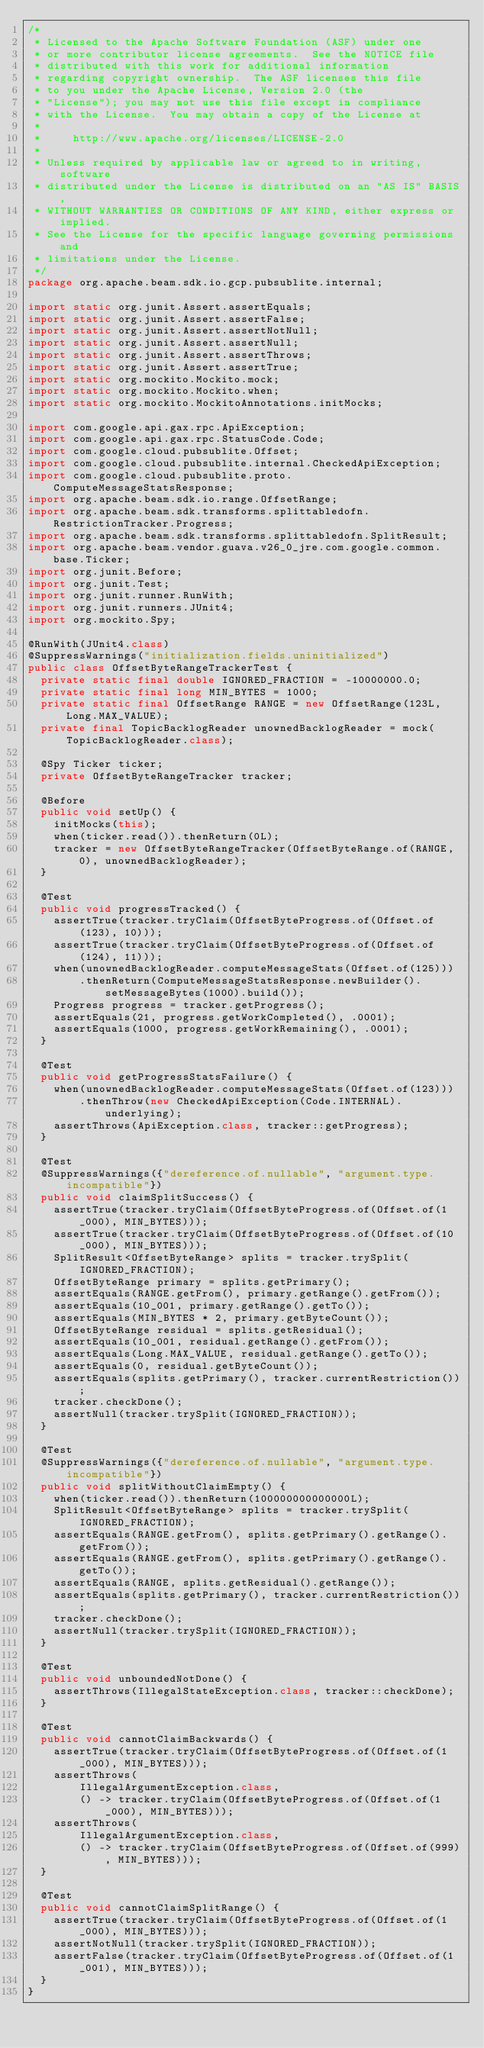Convert code to text. <code><loc_0><loc_0><loc_500><loc_500><_Java_>/*
 * Licensed to the Apache Software Foundation (ASF) under one
 * or more contributor license agreements.  See the NOTICE file
 * distributed with this work for additional information
 * regarding copyright ownership.  The ASF licenses this file
 * to you under the Apache License, Version 2.0 (the
 * "License"); you may not use this file except in compliance
 * with the License.  You may obtain a copy of the License at
 *
 *     http://www.apache.org/licenses/LICENSE-2.0
 *
 * Unless required by applicable law or agreed to in writing, software
 * distributed under the License is distributed on an "AS IS" BASIS,
 * WITHOUT WARRANTIES OR CONDITIONS OF ANY KIND, either express or implied.
 * See the License for the specific language governing permissions and
 * limitations under the License.
 */
package org.apache.beam.sdk.io.gcp.pubsublite.internal;

import static org.junit.Assert.assertEquals;
import static org.junit.Assert.assertFalse;
import static org.junit.Assert.assertNotNull;
import static org.junit.Assert.assertNull;
import static org.junit.Assert.assertThrows;
import static org.junit.Assert.assertTrue;
import static org.mockito.Mockito.mock;
import static org.mockito.Mockito.when;
import static org.mockito.MockitoAnnotations.initMocks;

import com.google.api.gax.rpc.ApiException;
import com.google.api.gax.rpc.StatusCode.Code;
import com.google.cloud.pubsublite.Offset;
import com.google.cloud.pubsublite.internal.CheckedApiException;
import com.google.cloud.pubsublite.proto.ComputeMessageStatsResponse;
import org.apache.beam.sdk.io.range.OffsetRange;
import org.apache.beam.sdk.transforms.splittabledofn.RestrictionTracker.Progress;
import org.apache.beam.sdk.transforms.splittabledofn.SplitResult;
import org.apache.beam.vendor.guava.v26_0_jre.com.google.common.base.Ticker;
import org.junit.Before;
import org.junit.Test;
import org.junit.runner.RunWith;
import org.junit.runners.JUnit4;
import org.mockito.Spy;

@RunWith(JUnit4.class)
@SuppressWarnings("initialization.fields.uninitialized")
public class OffsetByteRangeTrackerTest {
  private static final double IGNORED_FRACTION = -10000000.0;
  private static final long MIN_BYTES = 1000;
  private static final OffsetRange RANGE = new OffsetRange(123L, Long.MAX_VALUE);
  private final TopicBacklogReader unownedBacklogReader = mock(TopicBacklogReader.class);

  @Spy Ticker ticker;
  private OffsetByteRangeTracker tracker;

  @Before
  public void setUp() {
    initMocks(this);
    when(ticker.read()).thenReturn(0L);
    tracker = new OffsetByteRangeTracker(OffsetByteRange.of(RANGE, 0), unownedBacklogReader);
  }

  @Test
  public void progressTracked() {
    assertTrue(tracker.tryClaim(OffsetByteProgress.of(Offset.of(123), 10)));
    assertTrue(tracker.tryClaim(OffsetByteProgress.of(Offset.of(124), 11)));
    when(unownedBacklogReader.computeMessageStats(Offset.of(125)))
        .thenReturn(ComputeMessageStatsResponse.newBuilder().setMessageBytes(1000).build());
    Progress progress = tracker.getProgress();
    assertEquals(21, progress.getWorkCompleted(), .0001);
    assertEquals(1000, progress.getWorkRemaining(), .0001);
  }

  @Test
  public void getProgressStatsFailure() {
    when(unownedBacklogReader.computeMessageStats(Offset.of(123)))
        .thenThrow(new CheckedApiException(Code.INTERNAL).underlying);
    assertThrows(ApiException.class, tracker::getProgress);
  }

  @Test
  @SuppressWarnings({"dereference.of.nullable", "argument.type.incompatible"})
  public void claimSplitSuccess() {
    assertTrue(tracker.tryClaim(OffsetByteProgress.of(Offset.of(1_000), MIN_BYTES)));
    assertTrue(tracker.tryClaim(OffsetByteProgress.of(Offset.of(10_000), MIN_BYTES)));
    SplitResult<OffsetByteRange> splits = tracker.trySplit(IGNORED_FRACTION);
    OffsetByteRange primary = splits.getPrimary();
    assertEquals(RANGE.getFrom(), primary.getRange().getFrom());
    assertEquals(10_001, primary.getRange().getTo());
    assertEquals(MIN_BYTES * 2, primary.getByteCount());
    OffsetByteRange residual = splits.getResidual();
    assertEquals(10_001, residual.getRange().getFrom());
    assertEquals(Long.MAX_VALUE, residual.getRange().getTo());
    assertEquals(0, residual.getByteCount());
    assertEquals(splits.getPrimary(), tracker.currentRestriction());
    tracker.checkDone();
    assertNull(tracker.trySplit(IGNORED_FRACTION));
  }

  @Test
  @SuppressWarnings({"dereference.of.nullable", "argument.type.incompatible"})
  public void splitWithoutClaimEmpty() {
    when(ticker.read()).thenReturn(100000000000000L);
    SplitResult<OffsetByteRange> splits = tracker.trySplit(IGNORED_FRACTION);
    assertEquals(RANGE.getFrom(), splits.getPrimary().getRange().getFrom());
    assertEquals(RANGE.getFrom(), splits.getPrimary().getRange().getTo());
    assertEquals(RANGE, splits.getResidual().getRange());
    assertEquals(splits.getPrimary(), tracker.currentRestriction());
    tracker.checkDone();
    assertNull(tracker.trySplit(IGNORED_FRACTION));
  }

  @Test
  public void unboundedNotDone() {
    assertThrows(IllegalStateException.class, tracker::checkDone);
  }

  @Test
  public void cannotClaimBackwards() {
    assertTrue(tracker.tryClaim(OffsetByteProgress.of(Offset.of(1_000), MIN_BYTES)));
    assertThrows(
        IllegalArgumentException.class,
        () -> tracker.tryClaim(OffsetByteProgress.of(Offset.of(1_000), MIN_BYTES)));
    assertThrows(
        IllegalArgumentException.class,
        () -> tracker.tryClaim(OffsetByteProgress.of(Offset.of(999), MIN_BYTES)));
  }

  @Test
  public void cannotClaimSplitRange() {
    assertTrue(tracker.tryClaim(OffsetByteProgress.of(Offset.of(1_000), MIN_BYTES)));
    assertNotNull(tracker.trySplit(IGNORED_FRACTION));
    assertFalse(tracker.tryClaim(OffsetByteProgress.of(Offset.of(1_001), MIN_BYTES)));
  }
}
</code> 